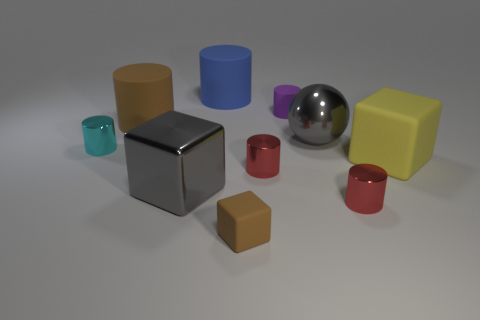Subtract 3 cylinders. How many cylinders are left? 3 Subtract all cyan cylinders. How many cylinders are left? 5 Subtract all brown cylinders. How many cylinders are left? 5 Subtract all yellow cylinders. Subtract all brown cubes. How many cylinders are left? 6 Subtract all cylinders. How many objects are left? 4 Subtract 1 gray balls. How many objects are left? 9 Subtract all gray things. Subtract all small cyan cylinders. How many objects are left? 7 Add 1 brown cubes. How many brown cubes are left? 2 Add 7 tiny yellow rubber cylinders. How many tiny yellow rubber cylinders exist? 7 